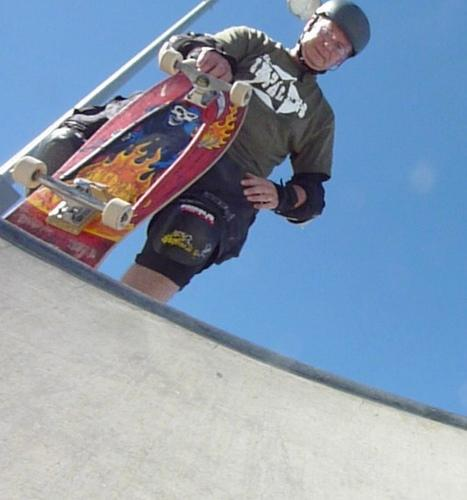Where is the man's hand positioned in the image? One of the man's hands is on the skateboard, while the other hand is placed on his hip. Which safety gear is the man in the image wearing? The man is wearing a gray safety helmet, glasses, black wrist guards, black knee pads, and a black elbow pad. Mention the key elements in the image that contribute to the visual entailment task. The gray safety helmet, orange and red flames on the skateboard, black knee pad with lettering, and the clear blue sky. If you were to use the image for a multi-choice VQA task, come up with a question and provide the right answer among the choices. Correct Answer: c) Gray Write a brief description of the man's outfit in the image. The man is wearing a grey shirt, black shorts, black knee pads, black wrist guards, and a gray safety helmet with glasses. Provide an accurate description of the helmet worn by the man in the image. The man is wearing a gray safety helmet with a black chin strap and green accents, as well as eyeglasses. Select an appropriate slogan for an advertisement showcasing the skateboard in the image. "Ride with style: Unleash your inner fire on our flame-designed skateboard with a bold skull face and smooth white wheels!" Describe the ramp the man is about to skateboard on. The ramp has a black lip, navy blue trim, and appears to be heading downward in a steep direction. In a narrative style, describe the atmosphere of the scene observed in the image. Under the clear blue and cloudless sky, an old man contemplates skateboarding on a ramp with a steep and downward direction, accompanied by his striking red and orange-flamed skateboard. What can you tell about the skateboard design in the picture? The skateboard has orange and red flames, a skull face, white wheels, and gray metal trucks. 